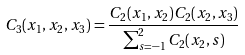Convert formula to latex. <formula><loc_0><loc_0><loc_500><loc_500>C _ { 3 } ( x _ { 1 } , x _ { 2 } , x _ { 3 } ) = \frac { C _ { 2 } ( x _ { 1 } , x _ { 2 } ) C _ { 2 } ( x _ { 2 } , x _ { 3 } ) } { \sum _ { s = - 1 } ^ { 2 } C _ { 2 } ( x _ { 2 } , s ) }</formula> 